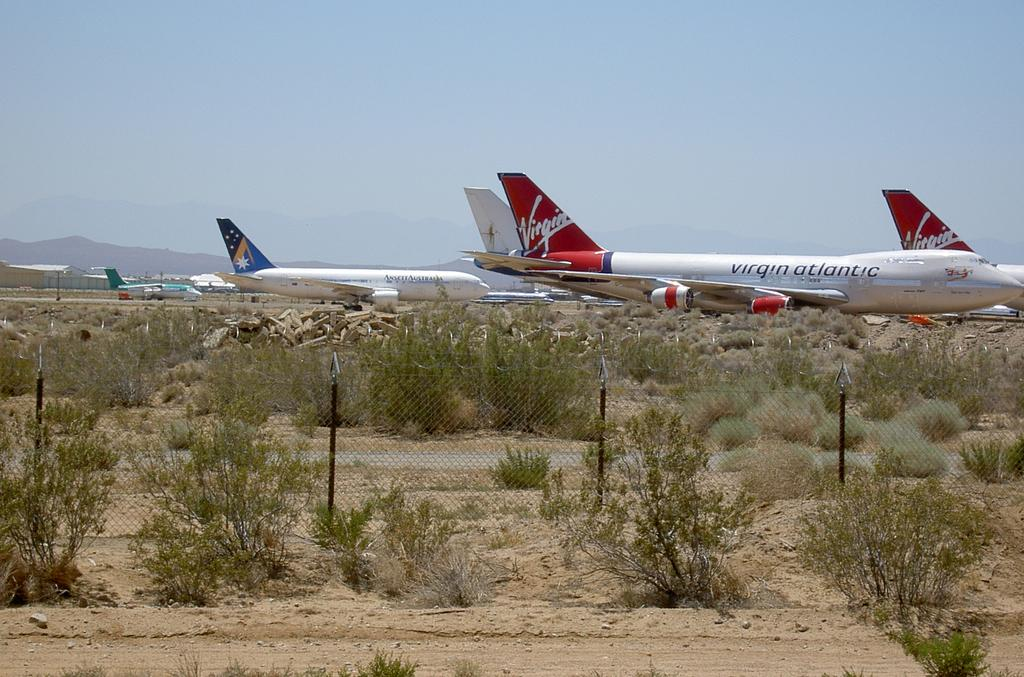<image>
Offer a succinct explanation of the picture presented. a virgin atlantic plane is one of several at this desert airport 